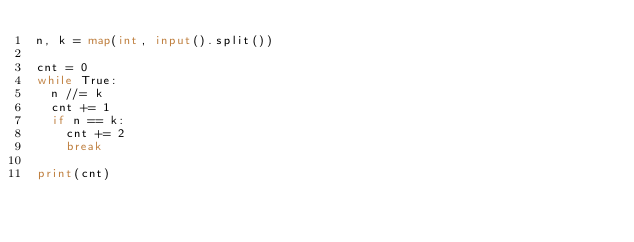Convert code to text. <code><loc_0><loc_0><loc_500><loc_500><_Python_>n, k = map(int, input().split())

cnt = 0
while True:
  n //= k
  cnt += 1
  if n == k:
    cnt += 2
    break
    
print(cnt)
  </code> 